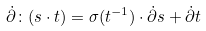Convert formula to latex. <formula><loc_0><loc_0><loc_500><loc_500>\dot { \partial } \colon ( s \cdot t ) = \sigma ( t ^ { - 1 } ) \cdot \dot { \partial } s + \dot { \partial } t</formula> 